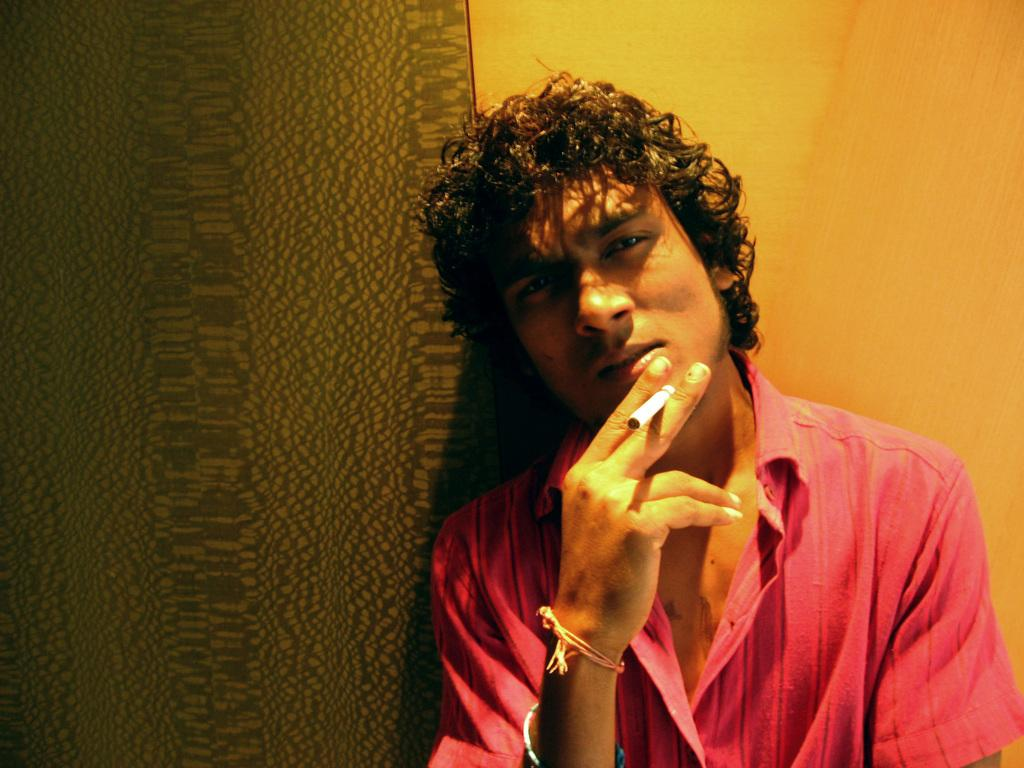What is present in the image? There is a man in the image. What is the man holding in the image? The man is holding a cigarette. What can be seen in the background of the image? There is a wall in the background of the image. What type of glove is the man wearing in the image? The man is not wearing any gloves in the image. What fact can be learned about the man's temper from the image? There is no information about the man's temper in the image. 